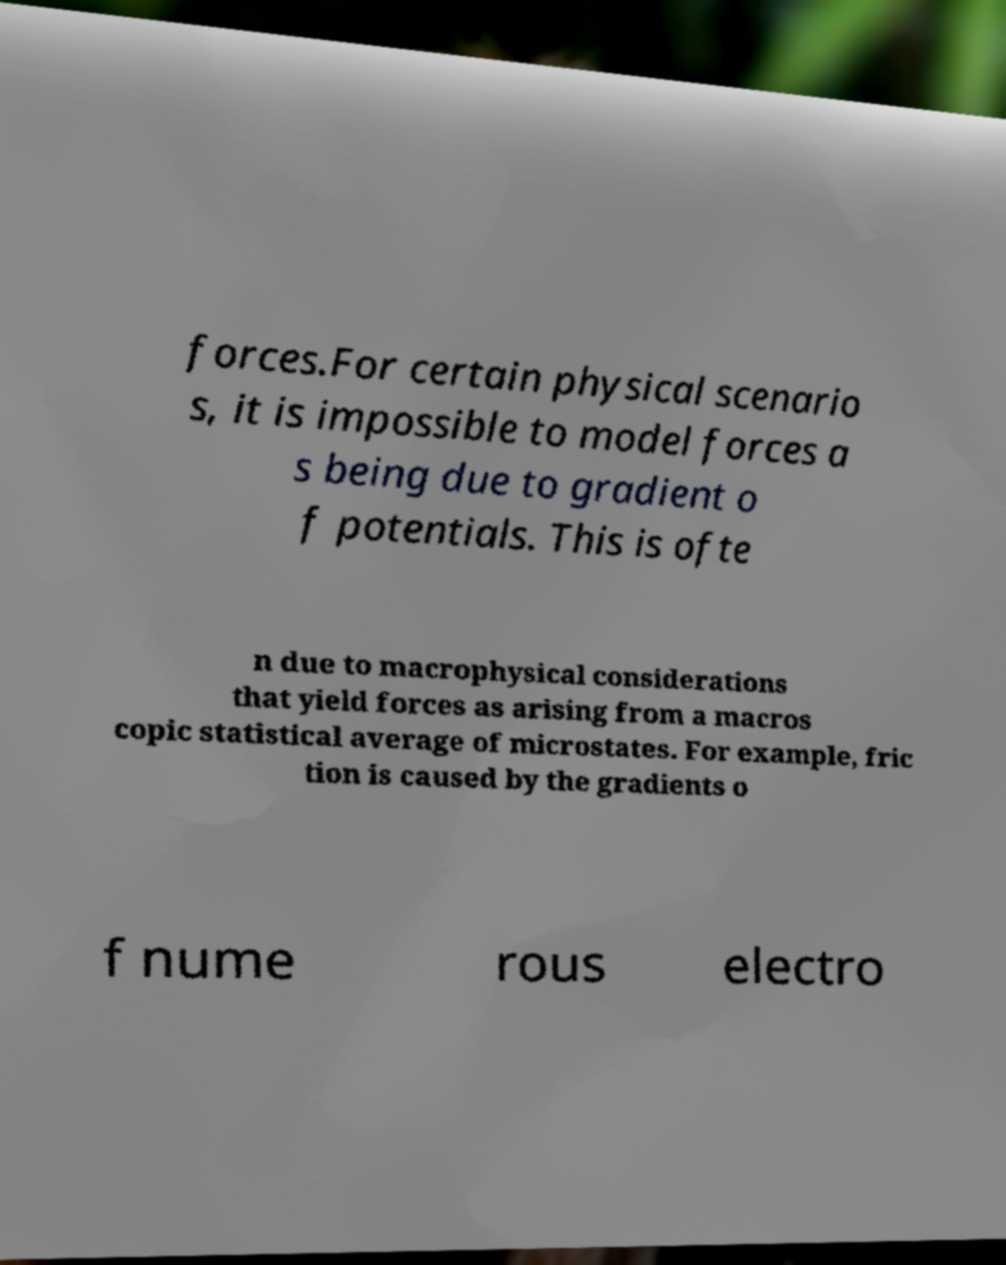There's text embedded in this image that I need extracted. Can you transcribe it verbatim? forces.For certain physical scenario s, it is impossible to model forces a s being due to gradient o f potentials. This is ofte n due to macrophysical considerations that yield forces as arising from a macros copic statistical average of microstates. For example, fric tion is caused by the gradients o f nume rous electro 